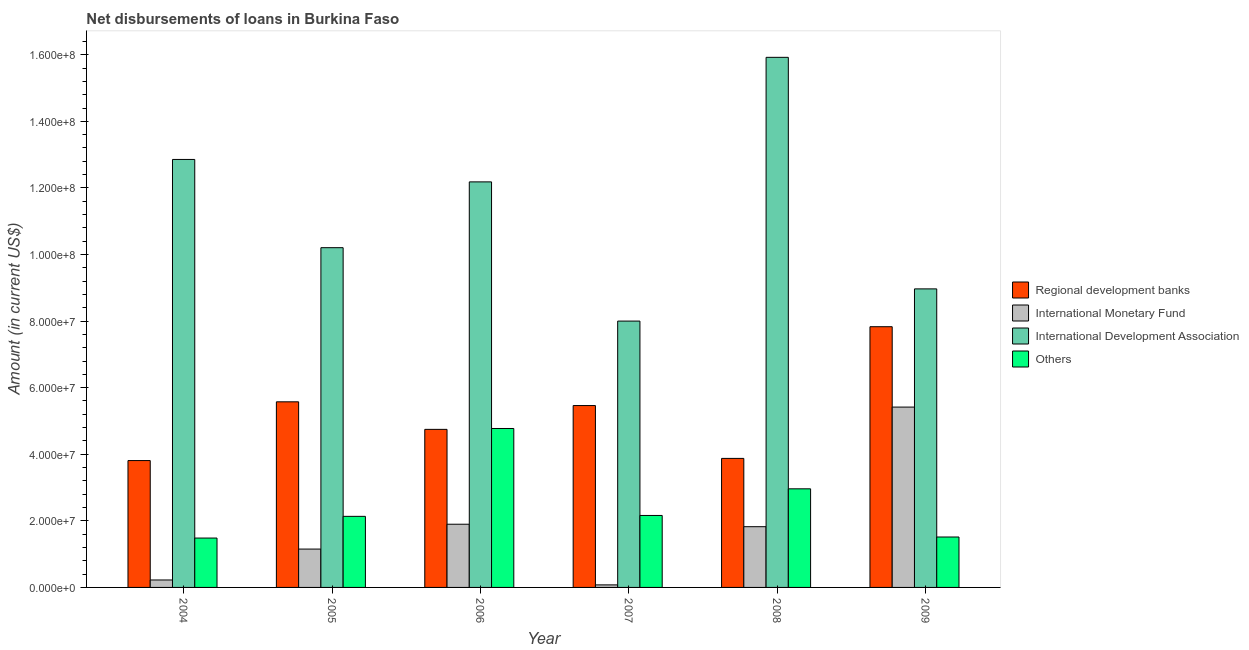How many different coloured bars are there?
Your answer should be very brief. 4. How many bars are there on the 5th tick from the left?
Offer a very short reply. 4. How many bars are there on the 2nd tick from the right?
Offer a terse response. 4. What is the label of the 2nd group of bars from the left?
Your answer should be compact. 2005. In how many cases, is the number of bars for a given year not equal to the number of legend labels?
Ensure brevity in your answer.  0. What is the amount of loan disimbursed by regional development banks in 2006?
Provide a short and direct response. 4.75e+07. Across all years, what is the maximum amount of loan disimbursed by regional development banks?
Offer a terse response. 7.83e+07. Across all years, what is the minimum amount of loan disimbursed by international development association?
Your answer should be very brief. 8.00e+07. In which year was the amount of loan disimbursed by international monetary fund minimum?
Your answer should be very brief. 2007. What is the total amount of loan disimbursed by international monetary fund in the graph?
Your response must be concise. 1.06e+08. What is the difference between the amount of loan disimbursed by international development association in 2007 and that in 2008?
Keep it short and to the point. -7.92e+07. What is the difference between the amount of loan disimbursed by international monetary fund in 2007 and the amount of loan disimbursed by other organisations in 2006?
Your response must be concise. -1.82e+07. What is the average amount of loan disimbursed by other organisations per year?
Provide a succinct answer. 2.50e+07. In how many years, is the amount of loan disimbursed by international development association greater than 20000000 US$?
Offer a terse response. 6. What is the ratio of the amount of loan disimbursed by regional development banks in 2004 to that in 2008?
Provide a short and direct response. 0.98. Is the amount of loan disimbursed by international development association in 2005 less than that in 2007?
Give a very brief answer. No. Is the difference between the amount of loan disimbursed by international development association in 2006 and 2007 greater than the difference between the amount of loan disimbursed by international monetary fund in 2006 and 2007?
Offer a very short reply. No. What is the difference between the highest and the second highest amount of loan disimbursed by other organisations?
Keep it short and to the point. 1.81e+07. What is the difference between the highest and the lowest amount of loan disimbursed by international development association?
Ensure brevity in your answer.  7.92e+07. In how many years, is the amount of loan disimbursed by international development association greater than the average amount of loan disimbursed by international development association taken over all years?
Give a very brief answer. 3. Is the sum of the amount of loan disimbursed by regional development banks in 2004 and 2007 greater than the maximum amount of loan disimbursed by international development association across all years?
Provide a short and direct response. Yes. Is it the case that in every year, the sum of the amount of loan disimbursed by other organisations and amount of loan disimbursed by regional development banks is greater than the sum of amount of loan disimbursed by international development association and amount of loan disimbursed by international monetary fund?
Ensure brevity in your answer.  No. What does the 2nd bar from the left in 2005 represents?
Provide a short and direct response. International Monetary Fund. What does the 2nd bar from the right in 2009 represents?
Your response must be concise. International Development Association. How many bars are there?
Ensure brevity in your answer.  24. Are all the bars in the graph horizontal?
Keep it short and to the point. No. How many years are there in the graph?
Offer a terse response. 6. What is the difference between two consecutive major ticks on the Y-axis?
Provide a succinct answer. 2.00e+07. Does the graph contain grids?
Offer a very short reply. No. How are the legend labels stacked?
Offer a terse response. Vertical. What is the title of the graph?
Your answer should be very brief. Net disbursements of loans in Burkina Faso. Does "Sweden" appear as one of the legend labels in the graph?
Provide a succinct answer. No. What is the label or title of the X-axis?
Offer a terse response. Year. What is the label or title of the Y-axis?
Your response must be concise. Amount (in current US$). What is the Amount (in current US$) in Regional development banks in 2004?
Offer a terse response. 3.81e+07. What is the Amount (in current US$) in International Monetary Fund in 2004?
Your response must be concise. 2.24e+06. What is the Amount (in current US$) in International Development Association in 2004?
Ensure brevity in your answer.  1.29e+08. What is the Amount (in current US$) of Others in 2004?
Keep it short and to the point. 1.48e+07. What is the Amount (in current US$) of Regional development banks in 2005?
Your response must be concise. 5.58e+07. What is the Amount (in current US$) of International Monetary Fund in 2005?
Your answer should be compact. 1.15e+07. What is the Amount (in current US$) in International Development Association in 2005?
Provide a succinct answer. 1.02e+08. What is the Amount (in current US$) in Others in 2005?
Offer a very short reply. 2.13e+07. What is the Amount (in current US$) of Regional development banks in 2006?
Ensure brevity in your answer.  4.75e+07. What is the Amount (in current US$) of International Monetary Fund in 2006?
Give a very brief answer. 1.90e+07. What is the Amount (in current US$) in International Development Association in 2006?
Offer a very short reply. 1.22e+08. What is the Amount (in current US$) in Others in 2006?
Offer a terse response. 4.77e+07. What is the Amount (in current US$) of Regional development banks in 2007?
Your answer should be compact. 5.46e+07. What is the Amount (in current US$) of International Monetary Fund in 2007?
Provide a succinct answer. 7.65e+05. What is the Amount (in current US$) in International Development Association in 2007?
Offer a very short reply. 8.00e+07. What is the Amount (in current US$) in Others in 2007?
Make the answer very short. 2.16e+07. What is the Amount (in current US$) of Regional development banks in 2008?
Provide a short and direct response. 3.88e+07. What is the Amount (in current US$) of International Monetary Fund in 2008?
Provide a succinct answer. 1.82e+07. What is the Amount (in current US$) of International Development Association in 2008?
Your answer should be compact. 1.59e+08. What is the Amount (in current US$) of Others in 2008?
Provide a short and direct response. 2.96e+07. What is the Amount (in current US$) of Regional development banks in 2009?
Your answer should be very brief. 7.83e+07. What is the Amount (in current US$) in International Monetary Fund in 2009?
Provide a succinct answer. 5.42e+07. What is the Amount (in current US$) of International Development Association in 2009?
Your answer should be compact. 8.97e+07. What is the Amount (in current US$) in Others in 2009?
Provide a succinct answer. 1.51e+07. Across all years, what is the maximum Amount (in current US$) of Regional development banks?
Keep it short and to the point. 7.83e+07. Across all years, what is the maximum Amount (in current US$) in International Monetary Fund?
Provide a succinct answer. 5.42e+07. Across all years, what is the maximum Amount (in current US$) of International Development Association?
Your answer should be very brief. 1.59e+08. Across all years, what is the maximum Amount (in current US$) of Others?
Give a very brief answer. 4.77e+07. Across all years, what is the minimum Amount (in current US$) in Regional development banks?
Ensure brevity in your answer.  3.81e+07. Across all years, what is the minimum Amount (in current US$) of International Monetary Fund?
Make the answer very short. 7.65e+05. Across all years, what is the minimum Amount (in current US$) of International Development Association?
Offer a very short reply. 8.00e+07. Across all years, what is the minimum Amount (in current US$) of Others?
Give a very brief answer. 1.48e+07. What is the total Amount (in current US$) of Regional development banks in the graph?
Provide a short and direct response. 3.13e+08. What is the total Amount (in current US$) of International Monetary Fund in the graph?
Your answer should be very brief. 1.06e+08. What is the total Amount (in current US$) of International Development Association in the graph?
Provide a succinct answer. 6.81e+08. What is the total Amount (in current US$) in Others in the graph?
Offer a terse response. 1.50e+08. What is the difference between the Amount (in current US$) in Regional development banks in 2004 and that in 2005?
Make the answer very short. -1.76e+07. What is the difference between the Amount (in current US$) of International Monetary Fund in 2004 and that in 2005?
Ensure brevity in your answer.  -9.28e+06. What is the difference between the Amount (in current US$) of International Development Association in 2004 and that in 2005?
Make the answer very short. 2.65e+07. What is the difference between the Amount (in current US$) in Others in 2004 and that in 2005?
Your response must be concise. -6.52e+06. What is the difference between the Amount (in current US$) in Regional development banks in 2004 and that in 2006?
Provide a short and direct response. -9.37e+06. What is the difference between the Amount (in current US$) of International Monetary Fund in 2004 and that in 2006?
Make the answer very short. -1.67e+07. What is the difference between the Amount (in current US$) in International Development Association in 2004 and that in 2006?
Your answer should be compact. 6.74e+06. What is the difference between the Amount (in current US$) of Others in 2004 and that in 2006?
Provide a short and direct response. -3.29e+07. What is the difference between the Amount (in current US$) in Regional development banks in 2004 and that in 2007?
Provide a succinct answer. -1.65e+07. What is the difference between the Amount (in current US$) of International Monetary Fund in 2004 and that in 2007?
Your answer should be very brief. 1.47e+06. What is the difference between the Amount (in current US$) in International Development Association in 2004 and that in 2007?
Your response must be concise. 4.86e+07. What is the difference between the Amount (in current US$) in Others in 2004 and that in 2007?
Your answer should be compact. -6.79e+06. What is the difference between the Amount (in current US$) of Regional development banks in 2004 and that in 2008?
Make the answer very short. -6.54e+05. What is the difference between the Amount (in current US$) in International Monetary Fund in 2004 and that in 2008?
Your response must be concise. -1.60e+07. What is the difference between the Amount (in current US$) of International Development Association in 2004 and that in 2008?
Keep it short and to the point. -3.07e+07. What is the difference between the Amount (in current US$) of Others in 2004 and that in 2008?
Provide a short and direct response. -1.48e+07. What is the difference between the Amount (in current US$) of Regional development banks in 2004 and that in 2009?
Your response must be concise. -4.02e+07. What is the difference between the Amount (in current US$) in International Monetary Fund in 2004 and that in 2009?
Your response must be concise. -5.19e+07. What is the difference between the Amount (in current US$) in International Development Association in 2004 and that in 2009?
Keep it short and to the point. 3.89e+07. What is the difference between the Amount (in current US$) of Others in 2004 and that in 2009?
Give a very brief answer. -3.14e+05. What is the difference between the Amount (in current US$) in Regional development banks in 2005 and that in 2006?
Keep it short and to the point. 8.28e+06. What is the difference between the Amount (in current US$) in International Monetary Fund in 2005 and that in 2006?
Make the answer very short. -7.46e+06. What is the difference between the Amount (in current US$) in International Development Association in 2005 and that in 2006?
Keep it short and to the point. -1.98e+07. What is the difference between the Amount (in current US$) in Others in 2005 and that in 2006?
Provide a short and direct response. -2.64e+07. What is the difference between the Amount (in current US$) in Regional development banks in 2005 and that in 2007?
Make the answer very short. 1.12e+06. What is the difference between the Amount (in current US$) of International Monetary Fund in 2005 and that in 2007?
Offer a terse response. 1.08e+07. What is the difference between the Amount (in current US$) in International Development Association in 2005 and that in 2007?
Make the answer very short. 2.20e+07. What is the difference between the Amount (in current US$) in Others in 2005 and that in 2007?
Your answer should be very brief. -2.67e+05. What is the difference between the Amount (in current US$) in Regional development banks in 2005 and that in 2008?
Your answer should be very brief. 1.70e+07. What is the difference between the Amount (in current US$) in International Monetary Fund in 2005 and that in 2008?
Your answer should be compact. -6.72e+06. What is the difference between the Amount (in current US$) of International Development Association in 2005 and that in 2008?
Offer a terse response. -5.72e+07. What is the difference between the Amount (in current US$) of Others in 2005 and that in 2008?
Make the answer very short. -8.27e+06. What is the difference between the Amount (in current US$) in Regional development banks in 2005 and that in 2009?
Offer a terse response. -2.26e+07. What is the difference between the Amount (in current US$) of International Monetary Fund in 2005 and that in 2009?
Ensure brevity in your answer.  -4.26e+07. What is the difference between the Amount (in current US$) of International Development Association in 2005 and that in 2009?
Your answer should be very brief. 1.24e+07. What is the difference between the Amount (in current US$) in Others in 2005 and that in 2009?
Your answer should be compact. 6.21e+06. What is the difference between the Amount (in current US$) of Regional development banks in 2006 and that in 2007?
Provide a short and direct response. -7.16e+06. What is the difference between the Amount (in current US$) of International Monetary Fund in 2006 and that in 2007?
Ensure brevity in your answer.  1.82e+07. What is the difference between the Amount (in current US$) in International Development Association in 2006 and that in 2007?
Offer a terse response. 4.18e+07. What is the difference between the Amount (in current US$) of Others in 2006 and that in 2007?
Provide a succinct answer. 2.61e+07. What is the difference between the Amount (in current US$) in Regional development banks in 2006 and that in 2008?
Give a very brief answer. 8.72e+06. What is the difference between the Amount (in current US$) of International Monetary Fund in 2006 and that in 2008?
Offer a very short reply. 7.42e+05. What is the difference between the Amount (in current US$) of International Development Association in 2006 and that in 2008?
Your response must be concise. -3.74e+07. What is the difference between the Amount (in current US$) of Others in 2006 and that in 2008?
Your response must be concise. 1.81e+07. What is the difference between the Amount (in current US$) in Regional development banks in 2006 and that in 2009?
Ensure brevity in your answer.  -3.08e+07. What is the difference between the Amount (in current US$) of International Monetary Fund in 2006 and that in 2009?
Your response must be concise. -3.52e+07. What is the difference between the Amount (in current US$) in International Development Association in 2006 and that in 2009?
Ensure brevity in your answer.  3.21e+07. What is the difference between the Amount (in current US$) of Others in 2006 and that in 2009?
Ensure brevity in your answer.  3.26e+07. What is the difference between the Amount (in current US$) of Regional development banks in 2007 and that in 2008?
Keep it short and to the point. 1.59e+07. What is the difference between the Amount (in current US$) of International Monetary Fund in 2007 and that in 2008?
Offer a terse response. -1.75e+07. What is the difference between the Amount (in current US$) of International Development Association in 2007 and that in 2008?
Give a very brief answer. -7.92e+07. What is the difference between the Amount (in current US$) of Others in 2007 and that in 2008?
Make the answer very short. -8.00e+06. What is the difference between the Amount (in current US$) in Regional development banks in 2007 and that in 2009?
Your response must be concise. -2.37e+07. What is the difference between the Amount (in current US$) of International Monetary Fund in 2007 and that in 2009?
Offer a very short reply. -5.34e+07. What is the difference between the Amount (in current US$) of International Development Association in 2007 and that in 2009?
Offer a terse response. -9.67e+06. What is the difference between the Amount (in current US$) of Others in 2007 and that in 2009?
Offer a terse response. 6.47e+06. What is the difference between the Amount (in current US$) in Regional development banks in 2008 and that in 2009?
Keep it short and to the point. -3.96e+07. What is the difference between the Amount (in current US$) of International Monetary Fund in 2008 and that in 2009?
Your answer should be compact. -3.59e+07. What is the difference between the Amount (in current US$) in International Development Association in 2008 and that in 2009?
Offer a very short reply. 6.95e+07. What is the difference between the Amount (in current US$) in Others in 2008 and that in 2009?
Make the answer very short. 1.45e+07. What is the difference between the Amount (in current US$) of Regional development banks in 2004 and the Amount (in current US$) of International Monetary Fund in 2005?
Provide a short and direct response. 2.66e+07. What is the difference between the Amount (in current US$) of Regional development banks in 2004 and the Amount (in current US$) of International Development Association in 2005?
Ensure brevity in your answer.  -6.39e+07. What is the difference between the Amount (in current US$) in Regional development banks in 2004 and the Amount (in current US$) in Others in 2005?
Offer a terse response. 1.68e+07. What is the difference between the Amount (in current US$) in International Monetary Fund in 2004 and the Amount (in current US$) in International Development Association in 2005?
Offer a terse response. -9.98e+07. What is the difference between the Amount (in current US$) in International Monetary Fund in 2004 and the Amount (in current US$) in Others in 2005?
Make the answer very short. -1.91e+07. What is the difference between the Amount (in current US$) in International Development Association in 2004 and the Amount (in current US$) in Others in 2005?
Ensure brevity in your answer.  1.07e+08. What is the difference between the Amount (in current US$) of Regional development banks in 2004 and the Amount (in current US$) of International Monetary Fund in 2006?
Your answer should be compact. 1.91e+07. What is the difference between the Amount (in current US$) of Regional development banks in 2004 and the Amount (in current US$) of International Development Association in 2006?
Keep it short and to the point. -8.37e+07. What is the difference between the Amount (in current US$) of Regional development banks in 2004 and the Amount (in current US$) of Others in 2006?
Your response must be concise. -9.64e+06. What is the difference between the Amount (in current US$) of International Monetary Fund in 2004 and the Amount (in current US$) of International Development Association in 2006?
Keep it short and to the point. -1.20e+08. What is the difference between the Amount (in current US$) of International Monetary Fund in 2004 and the Amount (in current US$) of Others in 2006?
Offer a terse response. -4.55e+07. What is the difference between the Amount (in current US$) in International Development Association in 2004 and the Amount (in current US$) in Others in 2006?
Provide a succinct answer. 8.08e+07. What is the difference between the Amount (in current US$) of Regional development banks in 2004 and the Amount (in current US$) of International Monetary Fund in 2007?
Ensure brevity in your answer.  3.73e+07. What is the difference between the Amount (in current US$) of Regional development banks in 2004 and the Amount (in current US$) of International Development Association in 2007?
Offer a very short reply. -4.19e+07. What is the difference between the Amount (in current US$) of Regional development banks in 2004 and the Amount (in current US$) of Others in 2007?
Give a very brief answer. 1.65e+07. What is the difference between the Amount (in current US$) in International Monetary Fund in 2004 and the Amount (in current US$) in International Development Association in 2007?
Ensure brevity in your answer.  -7.78e+07. What is the difference between the Amount (in current US$) in International Monetary Fund in 2004 and the Amount (in current US$) in Others in 2007?
Your answer should be compact. -1.94e+07. What is the difference between the Amount (in current US$) in International Development Association in 2004 and the Amount (in current US$) in Others in 2007?
Ensure brevity in your answer.  1.07e+08. What is the difference between the Amount (in current US$) of Regional development banks in 2004 and the Amount (in current US$) of International Monetary Fund in 2008?
Keep it short and to the point. 1.99e+07. What is the difference between the Amount (in current US$) in Regional development banks in 2004 and the Amount (in current US$) in International Development Association in 2008?
Make the answer very short. -1.21e+08. What is the difference between the Amount (in current US$) of Regional development banks in 2004 and the Amount (in current US$) of Others in 2008?
Ensure brevity in your answer.  8.49e+06. What is the difference between the Amount (in current US$) in International Monetary Fund in 2004 and the Amount (in current US$) in International Development Association in 2008?
Provide a short and direct response. -1.57e+08. What is the difference between the Amount (in current US$) of International Monetary Fund in 2004 and the Amount (in current US$) of Others in 2008?
Your answer should be very brief. -2.74e+07. What is the difference between the Amount (in current US$) in International Development Association in 2004 and the Amount (in current US$) in Others in 2008?
Offer a very short reply. 9.89e+07. What is the difference between the Amount (in current US$) in Regional development banks in 2004 and the Amount (in current US$) in International Monetary Fund in 2009?
Your response must be concise. -1.61e+07. What is the difference between the Amount (in current US$) in Regional development banks in 2004 and the Amount (in current US$) in International Development Association in 2009?
Provide a succinct answer. -5.16e+07. What is the difference between the Amount (in current US$) of Regional development banks in 2004 and the Amount (in current US$) of Others in 2009?
Provide a succinct answer. 2.30e+07. What is the difference between the Amount (in current US$) of International Monetary Fund in 2004 and the Amount (in current US$) of International Development Association in 2009?
Provide a succinct answer. -8.74e+07. What is the difference between the Amount (in current US$) in International Monetary Fund in 2004 and the Amount (in current US$) in Others in 2009?
Your response must be concise. -1.29e+07. What is the difference between the Amount (in current US$) of International Development Association in 2004 and the Amount (in current US$) of Others in 2009?
Ensure brevity in your answer.  1.13e+08. What is the difference between the Amount (in current US$) in Regional development banks in 2005 and the Amount (in current US$) in International Monetary Fund in 2006?
Keep it short and to the point. 3.68e+07. What is the difference between the Amount (in current US$) in Regional development banks in 2005 and the Amount (in current US$) in International Development Association in 2006?
Your answer should be compact. -6.61e+07. What is the difference between the Amount (in current US$) in Regional development banks in 2005 and the Amount (in current US$) in Others in 2006?
Ensure brevity in your answer.  8.01e+06. What is the difference between the Amount (in current US$) of International Monetary Fund in 2005 and the Amount (in current US$) of International Development Association in 2006?
Give a very brief answer. -1.10e+08. What is the difference between the Amount (in current US$) in International Monetary Fund in 2005 and the Amount (in current US$) in Others in 2006?
Your response must be concise. -3.62e+07. What is the difference between the Amount (in current US$) in International Development Association in 2005 and the Amount (in current US$) in Others in 2006?
Your response must be concise. 5.43e+07. What is the difference between the Amount (in current US$) of Regional development banks in 2005 and the Amount (in current US$) of International Monetary Fund in 2007?
Offer a terse response. 5.50e+07. What is the difference between the Amount (in current US$) of Regional development banks in 2005 and the Amount (in current US$) of International Development Association in 2007?
Your response must be concise. -2.42e+07. What is the difference between the Amount (in current US$) of Regional development banks in 2005 and the Amount (in current US$) of Others in 2007?
Offer a very short reply. 3.41e+07. What is the difference between the Amount (in current US$) of International Monetary Fund in 2005 and the Amount (in current US$) of International Development Association in 2007?
Your response must be concise. -6.85e+07. What is the difference between the Amount (in current US$) of International Monetary Fund in 2005 and the Amount (in current US$) of Others in 2007?
Provide a succinct answer. -1.01e+07. What is the difference between the Amount (in current US$) in International Development Association in 2005 and the Amount (in current US$) in Others in 2007?
Offer a terse response. 8.04e+07. What is the difference between the Amount (in current US$) of Regional development banks in 2005 and the Amount (in current US$) of International Monetary Fund in 2008?
Your answer should be very brief. 3.75e+07. What is the difference between the Amount (in current US$) of Regional development banks in 2005 and the Amount (in current US$) of International Development Association in 2008?
Make the answer very short. -1.03e+08. What is the difference between the Amount (in current US$) of Regional development banks in 2005 and the Amount (in current US$) of Others in 2008?
Offer a terse response. 2.61e+07. What is the difference between the Amount (in current US$) of International Monetary Fund in 2005 and the Amount (in current US$) of International Development Association in 2008?
Keep it short and to the point. -1.48e+08. What is the difference between the Amount (in current US$) in International Monetary Fund in 2005 and the Amount (in current US$) in Others in 2008?
Your answer should be compact. -1.81e+07. What is the difference between the Amount (in current US$) in International Development Association in 2005 and the Amount (in current US$) in Others in 2008?
Ensure brevity in your answer.  7.24e+07. What is the difference between the Amount (in current US$) of Regional development banks in 2005 and the Amount (in current US$) of International Monetary Fund in 2009?
Provide a succinct answer. 1.58e+06. What is the difference between the Amount (in current US$) of Regional development banks in 2005 and the Amount (in current US$) of International Development Association in 2009?
Ensure brevity in your answer.  -3.39e+07. What is the difference between the Amount (in current US$) of Regional development banks in 2005 and the Amount (in current US$) of Others in 2009?
Your response must be concise. 4.06e+07. What is the difference between the Amount (in current US$) in International Monetary Fund in 2005 and the Amount (in current US$) in International Development Association in 2009?
Provide a succinct answer. -7.82e+07. What is the difference between the Amount (in current US$) of International Monetary Fund in 2005 and the Amount (in current US$) of Others in 2009?
Make the answer very short. -3.62e+06. What is the difference between the Amount (in current US$) of International Development Association in 2005 and the Amount (in current US$) of Others in 2009?
Your answer should be very brief. 8.69e+07. What is the difference between the Amount (in current US$) of Regional development banks in 2006 and the Amount (in current US$) of International Monetary Fund in 2007?
Offer a very short reply. 4.67e+07. What is the difference between the Amount (in current US$) of Regional development banks in 2006 and the Amount (in current US$) of International Development Association in 2007?
Your answer should be very brief. -3.25e+07. What is the difference between the Amount (in current US$) in Regional development banks in 2006 and the Amount (in current US$) in Others in 2007?
Make the answer very short. 2.59e+07. What is the difference between the Amount (in current US$) of International Monetary Fund in 2006 and the Amount (in current US$) of International Development Association in 2007?
Offer a very short reply. -6.10e+07. What is the difference between the Amount (in current US$) of International Monetary Fund in 2006 and the Amount (in current US$) of Others in 2007?
Your response must be concise. -2.64e+06. What is the difference between the Amount (in current US$) of International Development Association in 2006 and the Amount (in current US$) of Others in 2007?
Offer a terse response. 1.00e+08. What is the difference between the Amount (in current US$) in Regional development banks in 2006 and the Amount (in current US$) in International Monetary Fund in 2008?
Offer a terse response. 2.92e+07. What is the difference between the Amount (in current US$) of Regional development banks in 2006 and the Amount (in current US$) of International Development Association in 2008?
Make the answer very short. -1.12e+08. What is the difference between the Amount (in current US$) in Regional development banks in 2006 and the Amount (in current US$) in Others in 2008?
Offer a terse response. 1.79e+07. What is the difference between the Amount (in current US$) of International Monetary Fund in 2006 and the Amount (in current US$) of International Development Association in 2008?
Your answer should be very brief. -1.40e+08. What is the difference between the Amount (in current US$) of International Monetary Fund in 2006 and the Amount (in current US$) of Others in 2008?
Your answer should be compact. -1.06e+07. What is the difference between the Amount (in current US$) in International Development Association in 2006 and the Amount (in current US$) in Others in 2008?
Your answer should be compact. 9.22e+07. What is the difference between the Amount (in current US$) of Regional development banks in 2006 and the Amount (in current US$) of International Monetary Fund in 2009?
Give a very brief answer. -6.70e+06. What is the difference between the Amount (in current US$) of Regional development banks in 2006 and the Amount (in current US$) of International Development Association in 2009?
Give a very brief answer. -4.22e+07. What is the difference between the Amount (in current US$) in Regional development banks in 2006 and the Amount (in current US$) in Others in 2009?
Give a very brief answer. 3.23e+07. What is the difference between the Amount (in current US$) in International Monetary Fund in 2006 and the Amount (in current US$) in International Development Association in 2009?
Provide a short and direct response. -7.07e+07. What is the difference between the Amount (in current US$) of International Monetary Fund in 2006 and the Amount (in current US$) of Others in 2009?
Ensure brevity in your answer.  3.84e+06. What is the difference between the Amount (in current US$) of International Development Association in 2006 and the Amount (in current US$) of Others in 2009?
Offer a very short reply. 1.07e+08. What is the difference between the Amount (in current US$) in Regional development banks in 2007 and the Amount (in current US$) in International Monetary Fund in 2008?
Make the answer very short. 3.64e+07. What is the difference between the Amount (in current US$) in Regional development banks in 2007 and the Amount (in current US$) in International Development Association in 2008?
Keep it short and to the point. -1.05e+08. What is the difference between the Amount (in current US$) in Regional development banks in 2007 and the Amount (in current US$) in Others in 2008?
Give a very brief answer. 2.50e+07. What is the difference between the Amount (in current US$) of International Monetary Fund in 2007 and the Amount (in current US$) of International Development Association in 2008?
Your answer should be very brief. -1.58e+08. What is the difference between the Amount (in current US$) in International Monetary Fund in 2007 and the Amount (in current US$) in Others in 2008?
Ensure brevity in your answer.  -2.88e+07. What is the difference between the Amount (in current US$) in International Development Association in 2007 and the Amount (in current US$) in Others in 2008?
Offer a very short reply. 5.04e+07. What is the difference between the Amount (in current US$) of Regional development banks in 2007 and the Amount (in current US$) of International Development Association in 2009?
Offer a very short reply. -3.50e+07. What is the difference between the Amount (in current US$) of Regional development banks in 2007 and the Amount (in current US$) of Others in 2009?
Your response must be concise. 3.95e+07. What is the difference between the Amount (in current US$) of International Monetary Fund in 2007 and the Amount (in current US$) of International Development Association in 2009?
Your response must be concise. -8.89e+07. What is the difference between the Amount (in current US$) in International Monetary Fund in 2007 and the Amount (in current US$) in Others in 2009?
Ensure brevity in your answer.  -1.44e+07. What is the difference between the Amount (in current US$) of International Development Association in 2007 and the Amount (in current US$) of Others in 2009?
Provide a succinct answer. 6.49e+07. What is the difference between the Amount (in current US$) of Regional development banks in 2008 and the Amount (in current US$) of International Monetary Fund in 2009?
Provide a short and direct response. -1.54e+07. What is the difference between the Amount (in current US$) of Regional development banks in 2008 and the Amount (in current US$) of International Development Association in 2009?
Your response must be concise. -5.09e+07. What is the difference between the Amount (in current US$) in Regional development banks in 2008 and the Amount (in current US$) in Others in 2009?
Offer a very short reply. 2.36e+07. What is the difference between the Amount (in current US$) in International Monetary Fund in 2008 and the Amount (in current US$) in International Development Association in 2009?
Offer a terse response. -7.14e+07. What is the difference between the Amount (in current US$) in International Monetary Fund in 2008 and the Amount (in current US$) in Others in 2009?
Provide a short and direct response. 3.10e+06. What is the difference between the Amount (in current US$) in International Development Association in 2008 and the Amount (in current US$) in Others in 2009?
Make the answer very short. 1.44e+08. What is the average Amount (in current US$) in Regional development banks per year?
Offer a very short reply. 5.22e+07. What is the average Amount (in current US$) in International Monetary Fund per year?
Provide a succinct answer. 1.77e+07. What is the average Amount (in current US$) of International Development Association per year?
Offer a terse response. 1.14e+08. What is the average Amount (in current US$) of Others per year?
Ensure brevity in your answer.  2.50e+07. In the year 2004, what is the difference between the Amount (in current US$) in Regional development banks and Amount (in current US$) in International Monetary Fund?
Your answer should be very brief. 3.59e+07. In the year 2004, what is the difference between the Amount (in current US$) in Regional development banks and Amount (in current US$) in International Development Association?
Offer a terse response. -9.04e+07. In the year 2004, what is the difference between the Amount (in current US$) of Regional development banks and Amount (in current US$) of Others?
Keep it short and to the point. 2.33e+07. In the year 2004, what is the difference between the Amount (in current US$) of International Monetary Fund and Amount (in current US$) of International Development Association?
Keep it short and to the point. -1.26e+08. In the year 2004, what is the difference between the Amount (in current US$) of International Monetary Fund and Amount (in current US$) of Others?
Provide a short and direct response. -1.26e+07. In the year 2004, what is the difference between the Amount (in current US$) in International Development Association and Amount (in current US$) in Others?
Provide a short and direct response. 1.14e+08. In the year 2005, what is the difference between the Amount (in current US$) in Regional development banks and Amount (in current US$) in International Monetary Fund?
Keep it short and to the point. 4.42e+07. In the year 2005, what is the difference between the Amount (in current US$) in Regional development banks and Amount (in current US$) in International Development Association?
Provide a short and direct response. -4.63e+07. In the year 2005, what is the difference between the Amount (in current US$) in Regional development banks and Amount (in current US$) in Others?
Provide a succinct answer. 3.44e+07. In the year 2005, what is the difference between the Amount (in current US$) of International Monetary Fund and Amount (in current US$) of International Development Association?
Offer a very short reply. -9.05e+07. In the year 2005, what is the difference between the Amount (in current US$) of International Monetary Fund and Amount (in current US$) of Others?
Offer a terse response. -9.83e+06. In the year 2005, what is the difference between the Amount (in current US$) of International Development Association and Amount (in current US$) of Others?
Ensure brevity in your answer.  8.07e+07. In the year 2006, what is the difference between the Amount (in current US$) in Regional development banks and Amount (in current US$) in International Monetary Fund?
Your answer should be compact. 2.85e+07. In the year 2006, what is the difference between the Amount (in current US$) in Regional development banks and Amount (in current US$) in International Development Association?
Offer a terse response. -7.43e+07. In the year 2006, what is the difference between the Amount (in current US$) of Regional development banks and Amount (in current US$) of Others?
Offer a very short reply. -2.64e+05. In the year 2006, what is the difference between the Amount (in current US$) in International Monetary Fund and Amount (in current US$) in International Development Association?
Provide a succinct answer. -1.03e+08. In the year 2006, what is the difference between the Amount (in current US$) of International Monetary Fund and Amount (in current US$) of Others?
Provide a succinct answer. -2.88e+07. In the year 2006, what is the difference between the Amount (in current US$) in International Development Association and Amount (in current US$) in Others?
Provide a succinct answer. 7.41e+07. In the year 2007, what is the difference between the Amount (in current US$) of Regional development banks and Amount (in current US$) of International Monetary Fund?
Give a very brief answer. 5.39e+07. In the year 2007, what is the difference between the Amount (in current US$) in Regional development banks and Amount (in current US$) in International Development Association?
Keep it short and to the point. -2.54e+07. In the year 2007, what is the difference between the Amount (in current US$) of Regional development banks and Amount (in current US$) of Others?
Offer a terse response. 3.30e+07. In the year 2007, what is the difference between the Amount (in current US$) of International Monetary Fund and Amount (in current US$) of International Development Association?
Make the answer very short. -7.92e+07. In the year 2007, what is the difference between the Amount (in current US$) of International Monetary Fund and Amount (in current US$) of Others?
Give a very brief answer. -2.09e+07. In the year 2007, what is the difference between the Amount (in current US$) in International Development Association and Amount (in current US$) in Others?
Provide a short and direct response. 5.84e+07. In the year 2008, what is the difference between the Amount (in current US$) of Regional development banks and Amount (in current US$) of International Monetary Fund?
Keep it short and to the point. 2.05e+07. In the year 2008, what is the difference between the Amount (in current US$) in Regional development banks and Amount (in current US$) in International Development Association?
Offer a terse response. -1.20e+08. In the year 2008, what is the difference between the Amount (in current US$) in Regional development banks and Amount (in current US$) in Others?
Keep it short and to the point. 9.14e+06. In the year 2008, what is the difference between the Amount (in current US$) of International Monetary Fund and Amount (in current US$) of International Development Association?
Give a very brief answer. -1.41e+08. In the year 2008, what is the difference between the Amount (in current US$) in International Monetary Fund and Amount (in current US$) in Others?
Provide a succinct answer. -1.14e+07. In the year 2008, what is the difference between the Amount (in current US$) of International Development Association and Amount (in current US$) of Others?
Provide a short and direct response. 1.30e+08. In the year 2009, what is the difference between the Amount (in current US$) of Regional development banks and Amount (in current US$) of International Monetary Fund?
Your answer should be very brief. 2.41e+07. In the year 2009, what is the difference between the Amount (in current US$) in Regional development banks and Amount (in current US$) in International Development Association?
Your answer should be very brief. -1.14e+07. In the year 2009, what is the difference between the Amount (in current US$) in Regional development banks and Amount (in current US$) in Others?
Provide a succinct answer. 6.32e+07. In the year 2009, what is the difference between the Amount (in current US$) in International Monetary Fund and Amount (in current US$) in International Development Association?
Make the answer very short. -3.55e+07. In the year 2009, what is the difference between the Amount (in current US$) of International Monetary Fund and Amount (in current US$) of Others?
Your answer should be very brief. 3.90e+07. In the year 2009, what is the difference between the Amount (in current US$) in International Development Association and Amount (in current US$) in Others?
Your answer should be very brief. 7.45e+07. What is the ratio of the Amount (in current US$) in Regional development banks in 2004 to that in 2005?
Ensure brevity in your answer.  0.68. What is the ratio of the Amount (in current US$) of International Monetary Fund in 2004 to that in 2005?
Your answer should be very brief. 0.19. What is the ratio of the Amount (in current US$) in International Development Association in 2004 to that in 2005?
Your response must be concise. 1.26. What is the ratio of the Amount (in current US$) in Others in 2004 to that in 2005?
Your answer should be very brief. 0.69. What is the ratio of the Amount (in current US$) in Regional development banks in 2004 to that in 2006?
Provide a succinct answer. 0.8. What is the ratio of the Amount (in current US$) of International Monetary Fund in 2004 to that in 2006?
Ensure brevity in your answer.  0.12. What is the ratio of the Amount (in current US$) of International Development Association in 2004 to that in 2006?
Offer a terse response. 1.06. What is the ratio of the Amount (in current US$) in Others in 2004 to that in 2006?
Offer a terse response. 0.31. What is the ratio of the Amount (in current US$) of Regional development banks in 2004 to that in 2007?
Provide a short and direct response. 0.7. What is the ratio of the Amount (in current US$) of International Monetary Fund in 2004 to that in 2007?
Offer a very short reply. 2.93. What is the ratio of the Amount (in current US$) of International Development Association in 2004 to that in 2007?
Provide a short and direct response. 1.61. What is the ratio of the Amount (in current US$) in Others in 2004 to that in 2007?
Your answer should be compact. 0.69. What is the ratio of the Amount (in current US$) in Regional development banks in 2004 to that in 2008?
Give a very brief answer. 0.98. What is the ratio of the Amount (in current US$) in International Monetary Fund in 2004 to that in 2008?
Provide a succinct answer. 0.12. What is the ratio of the Amount (in current US$) of International Development Association in 2004 to that in 2008?
Provide a short and direct response. 0.81. What is the ratio of the Amount (in current US$) of Others in 2004 to that in 2008?
Offer a terse response. 0.5. What is the ratio of the Amount (in current US$) of Regional development banks in 2004 to that in 2009?
Offer a terse response. 0.49. What is the ratio of the Amount (in current US$) of International Monetary Fund in 2004 to that in 2009?
Offer a terse response. 0.04. What is the ratio of the Amount (in current US$) in International Development Association in 2004 to that in 2009?
Keep it short and to the point. 1.43. What is the ratio of the Amount (in current US$) in Others in 2004 to that in 2009?
Your answer should be very brief. 0.98. What is the ratio of the Amount (in current US$) in Regional development banks in 2005 to that in 2006?
Your answer should be very brief. 1.17. What is the ratio of the Amount (in current US$) of International Monetary Fund in 2005 to that in 2006?
Offer a terse response. 0.61. What is the ratio of the Amount (in current US$) of International Development Association in 2005 to that in 2006?
Ensure brevity in your answer.  0.84. What is the ratio of the Amount (in current US$) in Others in 2005 to that in 2006?
Ensure brevity in your answer.  0.45. What is the ratio of the Amount (in current US$) in Regional development banks in 2005 to that in 2007?
Your answer should be very brief. 1.02. What is the ratio of the Amount (in current US$) in International Monetary Fund in 2005 to that in 2007?
Your response must be concise. 15.06. What is the ratio of the Amount (in current US$) of International Development Association in 2005 to that in 2007?
Ensure brevity in your answer.  1.28. What is the ratio of the Amount (in current US$) in Others in 2005 to that in 2007?
Make the answer very short. 0.99. What is the ratio of the Amount (in current US$) in Regional development banks in 2005 to that in 2008?
Provide a succinct answer. 1.44. What is the ratio of the Amount (in current US$) in International Monetary Fund in 2005 to that in 2008?
Provide a succinct answer. 0.63. What is the ratio of the Amount (in current US$) in International Development Association in 2005 to that in 2008?
Your response must be concise. 0.64. What is the ratio of the Amount (in current US$) in Others in 2005 to that in 2008?
Your response must be concise. 0.72. What is the ratio of the Amount (in current US$) of Regional development banks in 2005 to that in 2009?
Offer a very short reply. 0.71. What is the ratio of the Amount (in current US$) in International Monetary Fund in 2005 to that in 2009?
Provide a succinct answer. 0.21. What is the ratio of the Amount (in current US$) of International Development Association in 2005 to that in 2009?
Your answer should be very brief. 1.14. What is the ratio of the Amount (in current US$) of Others in 2005 to that in 2009?
Provide a short and direct response. 1.41. What is the ratio of the Amount (in current US$) in Regional development banks in 2006 to that in 2007?
Offer a very short reply. 0.87. What is the ratio of the Amount (in current US$) of International Monetary Fund in 2006 to that in 2007?
Offer a very short reply. 24.81. What is the ratio of the Amount (in current US$) in International Development Association in 2006 to that in 2007?
Offer a very short reply. 1.52. What is the ratio of the Amount (in current US$) of Others in 2006 to that in 2007?
Your answer should be compact. 2.21. What is the ratio of the Amount (in current US$) of Regional development banks in 2006 to that in 2008?
Offer a very short reply. 1.23. What is the ratio of the Amount (in current US$) of International Monetary Fund in 2006 to that in 2008?
Ensure brevity in your answer.  1.04. What is the ratio of the Amount (in current US$) in International Development Association in 2006 to that in 2008?
Offer a very short reply. 0.77. What is the ratio of the Amount (in current US$) of Others in 2006 to that in 2008?
Offer a terse response. 1.61. What is the ratio of the Amount (in current US$) in Regional development banks in 2006 to that in 2009?
Offer a terse response. 0.61. What is the ratio of the Amount (in current US$) in International Monetary Fund in 2006 to that in 2009?
Offer a very short reply. 0.35. What is the ratio of the Amount (in current US$) of International Development Association in 2006 to that in 2009?
Keep it short and to the point. 1.36. What is the ratio of the Amount (in current US$) of Others in 2006 to that in 2009?
Your answer should be compact. 3.15. What is the ratio of the Amount (in current US$) of Regional development banks in 2007 to that in 2008?
Your answer should be compact. 1.41. What is the ratio of the Amount (in current US$) in International Monetary Fund in 2007 to that in 2008?
Ensure brevity in your answer.  0.04. What is the ratio of the Amount (in current US$) in International Development Association in 2007 to that in 2008?
Your answer should be compact. 0.5. What is the ratio of the Amount (in current US$) in Others in 2007 to that in 2008?
Your answer should be very brief. 0.73. What is the ratio of the Amount (in current US$) of Regional development banks in 2007 to that in 2009?
Give a very brief answer. 0.7. What is the ratio of the Amount (in current US$) in International Monetary Fund in 2007 to that in 2009?
Offer a terse response. 0.01. What is the ratio of the Amount (in current US$) of International Development Association in 2007 to that in 2009?
Give a very brief answer. 0.89. What is the ratio of the Amount (in current US$) of Others in 2007 to that in 2009?
Your answer should be very brief. 1.43. What is the ratio of the Amount (in current US$) in Regional development banks in 2008 to that in 2009?
Offer a very short reply. 0.49. What is the ratio of the Amount (in current US$) in International Monetary Fund in 2008 to that in 2009?
Provide a succinct answer. 0.34. What is the ratio of the Amount (in current US$) of International Development Association in 2008 to that in 2009?
Provide a short and direct response. 1.78. What is the ratio of the Amount (in current US$) in Others in 2008 to that in 2009?
Give a very brief answer. 1.96. What is the difference between the highest and the second highest Amount (in current US$) of Regional development banks?
Your response must be concise. 2.26e+07. What is the difference between the highest and the second highest Amount (in current US$) in International Monetary Fund?
Ensure brevity in your answer.  3.52e+07. What is the difference between the highest and the second highest Amount (in current US$) in International Development Association?
Make the answer very short. 3.07e+07. What is the difference between the highest and the second highest Amount (in current US$) of Others?
Your answer should be very brief. 1.81e+07. What is the difference between the highest and the lowest Amount (in current US$) in Regional development banks?
Keep it short and to the point. 4.02e+07. What is the difference between the highest and the lowest Amount (in current US$) in International Monetary Fund?
Keep it short and to the point. 5.34e+07. What is the difference between the highest and the lowest Amount (in current US$) in International Development Association?
Ensure brevity in your answer.  7.92e+07. What is the difference between the highest and the lowest Amount (in current US$) in Others?
Your answer should be very brief. 3.29e+07. 